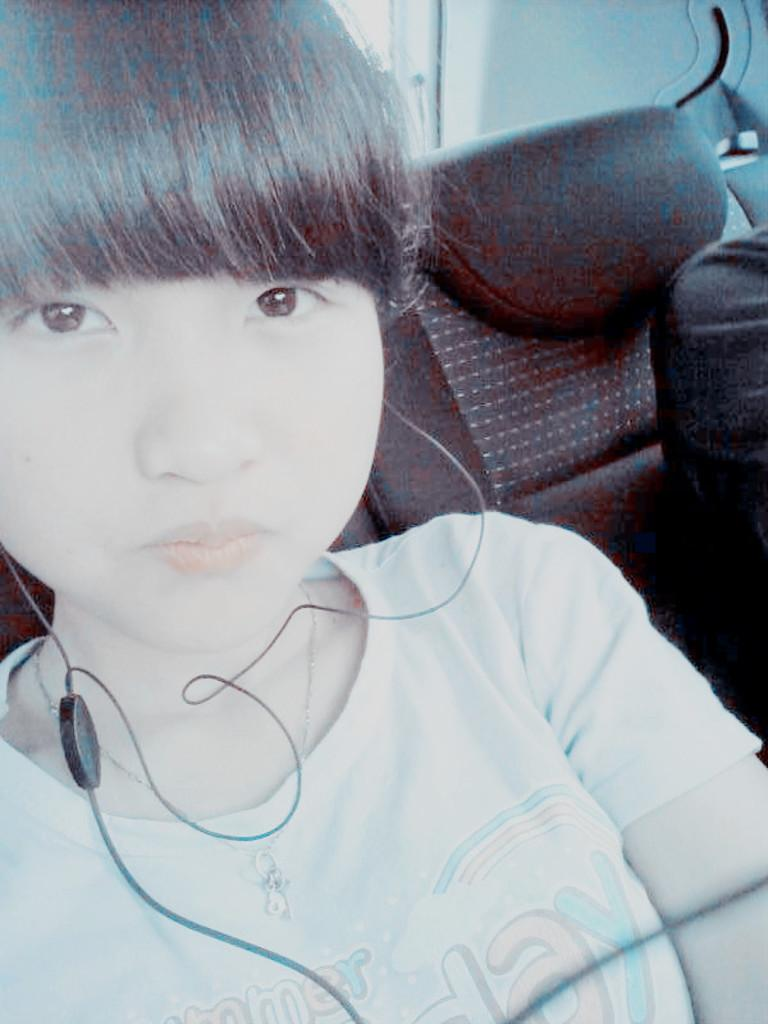Who is the main subject in the image? There is a girl in the image. What is the girl wearing on her upper body? The girl is wearing a T-shirt. What type of accessory is the girl wearing? The girl is wearing jewelry. What can be seen in the image that might be used for listening to music or other audio? Earphones are visible in the image. Who else is present in the image besides the girl? There is another person in the image. What is on the left side of the image that might be used for sitting? There is a seat on the left side of the image. What arithmetic problem is the girl solving in the image? There is no arithmetic problem visible in the image. What type of pie is the girl holding in the image? There is no pie present in the image. 